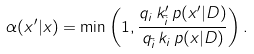Convert formula to latex. <formula><loc_0><loc_0><loc_500><loc_500>\alpha ( x ^ { \prime } | x ) = \min \left ( 1 , \frac { q _ { i } \, k _ { \tilde { i } } ^ { \prime } \, p ( x ^ { \prime } | D ) } { q _ { \tilde { i } } \, k _ { i } \, p ( x | D ) } \right ) .</formula> 